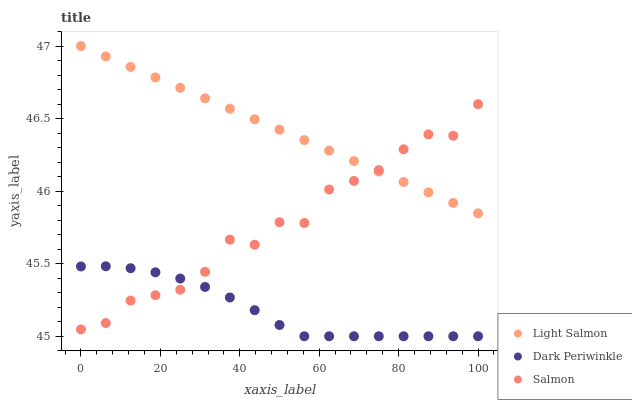Does Dark Periwinkle have the minimum area under the curve?
Answer yes or no. Yes. Does Light Salmon have the maximum area under the curve?
Answer yes or no. Yes. Does Salmon have the minimum area under the curve?
Answer yes or no. No. Does Salmon have the maximum area under the curve?
Answer yes or no. No. Is Light Salmon the smoothest?
Answer yes or no. Yes. Is Salmon the roughest?
Answer yes or no. Yes. Is Dark Periwinkle the smoothest?
Answer yes or no. No. Is Dark Periwinkle the roughest?
Answer yes or no. No. Does Dark Periwinkle have the lowest value?
Answer yes or no. Yes. Does Salmon have the lowest value?
Answer yes or no. No. Does Light Salmon have the highest value?
Answer yes or no. Yes. Does Salmon have the highest value?
Answer yes or no. No. Is Dark Periwinkle less than Light Salmon?
Answer yes or no. Yes. Is Light Salmon greater than Dark Periwinkle?
Answer yes or no. Yes. Does Salmon intersect Dark Periwinkle?
Answer yes or no. Yes. Is Salmon less than Dark Periwinkle?
Answer yes or no. No. Is Salmon greater than Dark Periwinkle?
Answer yes or no. No. Does Dark Periwinkle intersect Light Salmon?
Answer yes or no. No. 